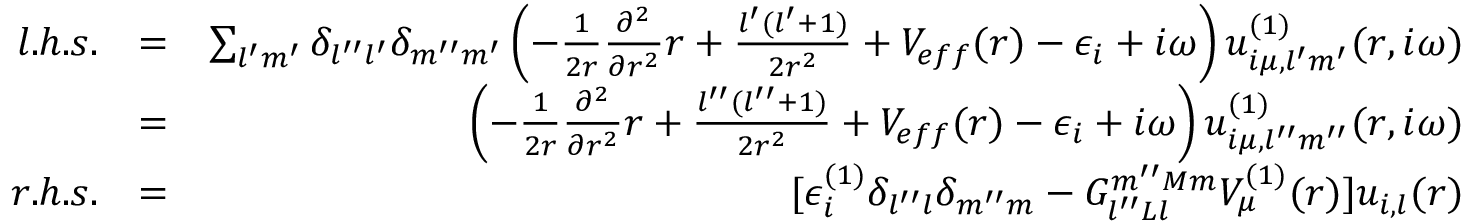<formula> <loc_0><loc_0><loc_500><loc_500>\begin{array} { r l r } { l . h . s . } & { = } & { \sum _ { l ^ { \prime } m ^ { \prime } } \delta _ { l ^ { \prime \prime } l ^ { \prime } } \delta _ { m ^ { \prime \prime } m ^ { \prime } } \left ( - \frac { 1 } { 2 r } \frac { \partial ^ { 2 } } { \partial r ^ { 2 } } r + \frac { l ^ { \prime } ( l ^ { \prime } + 1 ) } { 2 r ^ { 2 } } + V _ { e f f } ( r ) - \epsilon _ { i } + i \omega \right ) u _ { i \mu , l ^ { \prime } m ^ { \prime } } ^ { ( 1 ) } ( r , i \omega ) } \\ & { = } & { \left ( - \frac { 1 } { 2 r } \frac { \partial ^ { 2 } } { \partial r ^ { 2 } } r + \frac { l ^ { \prime \prime } ( l ^ { \prime \prime } + 1 ) } { 2 r ^ { 2 } } + V _ { e f f } ( r ) - \epsilon _ { i } + i \omega \right ) u _ { i \mu , l ^ { \prime \prime } m ^ { \prime \prime } } ^ { ( 1 ) } ( r , i \omega ) } \\ { r . h . s . } & { = } & { [ \epsilon _ { i } ^ { ( 1 ) } \delta _ { l ^ { \prime \prime } l } \delta _ { m ^ { \prime \prime } m } - G _ { l ^ { \prime \prime } L l } ^ { m ^ { \prime \prime } M m } V _ { \mu } ^ { ( 1 ) } ( r ) ] u _ { i , l } ( r ) } \end{array}</formula> 